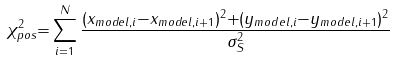Convert formula to latex. <formula><loc_0><loc_0><loc_500><loc_500>\chi ^ { 2 } _ { p o s } { = } \sum _ { i { = } 1 } ^ { N } \frac { ( x _ { m o d e l , i } { - } x _ { m o d e l , i + 1 } ) ^ { 2 } { + } ( y _ { m o d e l , i } { - } y _ { m o d e l , i + 1 } ) ^ { 2 } } { \sigma _ { S } ^ { 2 } }</formula> 